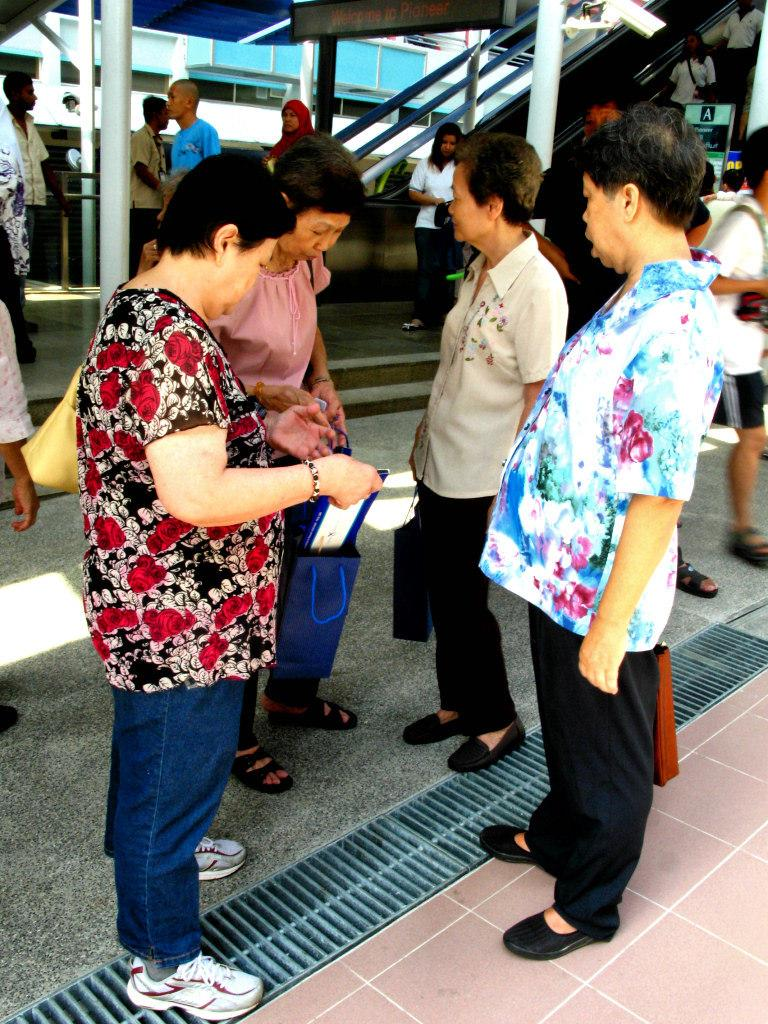How many people are present in the image? There is a group of people standing in the image. What can be seen in the background of the image? There is a shed in the background of the image. Are there any people inside the shed? Yes, there are people standing inside the shed. What type of structure is present in the image that helps people move between levels? There is an escalator in the image. What type of patch can be seen on the field in the image? There is no field or patch present in the image. How many stamps are visible on the people in the image? There are no stamps visible on the people in the image. 